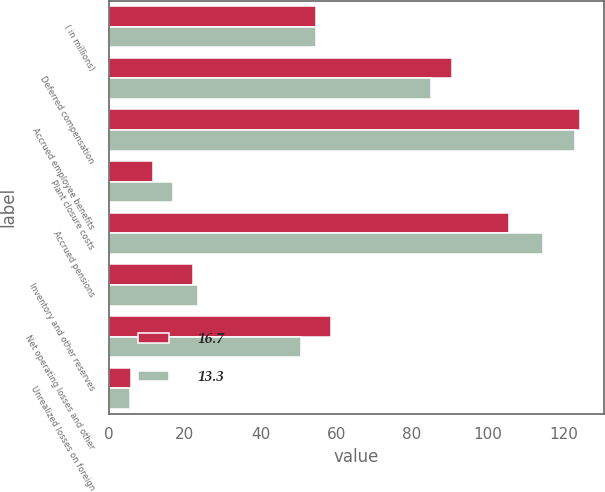Convert chart to OTSL. <chart><loc_0><loc_0><loc_500><loc_500><stacked_bar_chart><ecel><fcel>( in millions)<fcel>Deferred compensation<fcel>Accrued employee benefits<fcel>Plant closure costs<fcel>Accrued pensions<fcel>Inventory and other reserves<fcel>Net operating losses and other<fcel>Unrealized losses on foreign<nl><fcel>16.7<fcel>54.65<fcel>90.6<fcel>124.4<fcel>11.5<fcel>105.6<fcel>22.1<fcel>58.5<fcel>5.7<nl><fcel>13.3<fcel>54.65<fcel>85<fcel>123.2<fcel>17<fcel>114.5<fcel>23.6<fcel>50.8<fcel>5.6<nl></chart> 